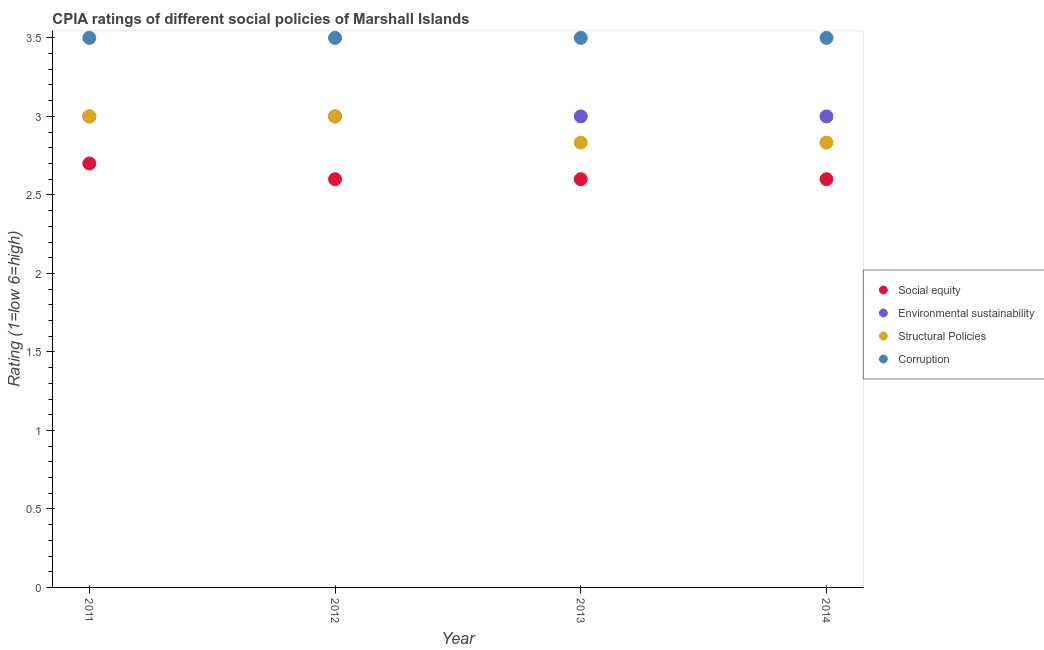How many different coloured dotlines are there?
Provide a succinct answer. 4. Is the number of dotlines equal to the number of legend labels?
Your answer should be compact. Yes. What is the cpia rating of environmental sustainability in 2011?
Your answer should be compact. 3. Across all years, what is the minimum cpia rating of structural policies?
Give a very brief answer. 2.83. In which year was the cpia rating of environmental sustainability minimum?
Provide a succinct answer. 2011. What is the average cpia rating of structural policies per year?
Provide a succinct answer. 2.92. In the year 2014, what is the difference between the cpia rating of social equity and cpia rating of structural policies?
Your response must be concise. -0.23. In how many years, is the cpia rating of social equity greater than 3.3?
Provide a short and direct response. 0. What is the ratio of the cpia rating of social equity in 2013 to that in 2014?
Make the answer very short. 1. Is the cpia rating of structural policies in 2012 less than that in 2014?
Provide a short and direct response. No. Is the difference between the cpia rating of structural policies in 2011 and 2012 greater than the difference between the cpia rating of social equity in 2011 and 2012?
Your answer should be very brief. No. What is the difference between the highest and the second highest cpia rating of structural policies?
Keep it short and to the point. 0. In how many years, is the cpia rating of corruption greater than the average cpia rating of corruption taken over all years?
Make the answer very short. 0. Is the sum of the cpia rating of structural policies in 2011 and 2014 greater than the maximum cpia rating of corruption across all years?
Keep it short and to the point. Yes. Is it the case that in every year, the sum of the cpia rating of structural policies and cpia rating of social equity is greater than the sum of cpia rating of corruption and cpia rating of environmental sustainability?
Your response must be concise. Yes. Is it the case that in every year, the sum of the cpia rating of social equity and cpia rating of environmental sustainability is greater than the cpia rating of structural policies?
Give a very brief answer. Yes. Is the cpia rating of social equity strictly less than the cpia rating of corruption over the years?
Provide a succinct answer. Yes. How many dotlines are there?
Offer a very short reply. 4. What is the difference between two consecutive major ticks on the Y-axis?
Make the answer very short. 0.5. Are the values on the major ticks of Y-axis written in scientific E-notation?
Give a very brief answer. No. How many legend labels are there?
Your answer should be very brief. 4. What is the title of the graph?
Provide a short and direct response. CPIA ratings of different social policies of Marshall Islands. What is the label or title of the X-axis?
Make the answer very short. Year. What is the Rating (1=low 6=high) in Corruption in 2011?
Your answer should be compact. 3.5. What is the Rating (1=low 6=high) in Social equity in 2012?
Give a very brief answer. 2.6. What is the Rating (1=low 6=high) of Structural Policies in 2012?
Offer a very short reply. 3. What is the Rating (1=low 6=high) in Social equity in 2013?
Your answer should be very brief. 2.6. What is the Rating (1=low 6=high) of Environmental sustainability in 2013?
Provide a short and direct response. 3. What is the Rating (1=low 6=high) of Structural Policies in 2013?
Make the answer very short. 2.83. What is the Rating (1=low 6=high) of Corruption in 2013?
Your answer should be very brief. 3.5. What is the Rating (1=low 6=high) of Social equity in 2014?
Ensure brevity in your answer.  2.6. What is the Rating (1=low 6=high) of Environmental sustainability in 2014?
Your answer should be compact. 3. What is the Rating (1=low 6=high) in Structural Policies in 2014?
Your response must be concise. 2.83. What is the Rating (1=low 6=high) in Corruption in 2014?
Offer a terse response. 3.5. Across all years, what is the maximum Rating (1=low 6=high) in Social equity?
Provide a succinct answer. 2.7. Across all years, what is the maximum Rating (1=low 6=high) in Environmental sustainability?
Ensure brevity in your answer.  3. Across all years, what is the maximum Rating (1=low 6=high) in Structural Policies?
Your response must be concise. 3. Across all years, what is the minimum Rating (1=low 6=high) of Structural Policies?
Offer a very short reply. 2.83. What is the total Rating (1=low 6=high) of Environmental sustainability in the graph?
Provide a succinct answer. 12. What is the total Rating (1=low 6=high) in Structural Policies in the graph?
Offer a very short reply. 11.67. What is the difference between the Rating (1=low 6=high) in Social equity in 2011 and that in 2012?
Your answer should be very brief. 0.1. What is the difference between the Rating (1=low 6=high) in Environmental sustainability in 2011 and that in 2012?
Your response must be concise. 0. What is the difference between the Rating (1=low 6=high) in Structural Policies in 2011 and that in 2012?
Your answer should be compact. 0. What is the difference between the Rating (1=low 6=high) in Social equity in 2011 and that in 2013?
Offer a terse response. 0.1. What is the difference between the Rating (1=low 6=high) of Structural Policies in 2011 and that in 2013?
Your response must be concise. 0.17. What is the difference between the Rating (1=low 6=high) of Corruption in 2011 and that in 2013?
Make the answer very short. 0. What is the difference between the Rating (1=low 6=high) in Social equity in 2012 and that in 2013?
Give a very brief answer. 0. What is the difference between the Rating (1=low 6=high) in Environmental sustainability in 2012 and that in 2013?
Your response must be concise. 0. What is the difference between the Rating (1=low 6=high) of Structural Policies in 2012 and that in 2013?
Ensure brevity in your answer.  0.17. What is the difference between the Rating (1=low 6=high) in Corruption in 2012 and that in 2013?
Your answer should be compact. 0. What is the difference between the Rating (1=low 6=high) in Social equity in 2012 and that in 2014?
Give a very brief answer. 0. What is the difference between the Rating (1=low 6=high) of Environmental sustainability in 2012 and that in 2014?
Your response must be concise. 0. What is the difference between the Rating (1=low 6=high) in Corruption in 2012 and that in 2014?
Your response must be concise. 0. What is the difference between the Rating (1=low 6=high) in Structural Policies in 2013 and that in 2014?
Provide a succinct answer. 0. What is the difference between the Rating (1=low 6=high) of Social equity in 2011 and the Rating (1=low 6=high) of Structural Policies in 2012?
Your answer should be very brief. -0.3. What is the difference between the Rating (1=low 6=high) in Social equity in 2011 and the Rating (1=low 6=high) in Corruption in 2012?
Offer a terse response. -0.8. What is the difference between the Rating (1=low 6=high) of Environmental sustainability in 2011 and the Rating (1=low 6=high) of Structural Policies in 2012?
Provide a short and direct response. 0. What is the difference between the Rating (1=low 6=high) in Environmental sustainability in 2011 and the Rating (1=low 6=high) in Corruption in 2012?
Offer a terse response. -0.5. What is the difference between the Rating (1=low 6=high) of Social equity in 2011 and the Rating (1=low 6=high) of Environmental sustainability in 2013?
Make the answer very short. -0.3. What is the difference between the Rating (1=low 6=high) in Social equity in 2011 and the Rating (1=low 6=high) in Structural Policies in 2013?
Give a very brief answer. -0.13. What is the difference between the Rating (1=low 6=high) in Social equity in 2011 and the Rating (1=low 6=high) in Corruption in 2013?
Your answer should be very brief. -0.8. What is the difference between the Rating (1=low 6=high) of Environmental sustainability in 2011 and the Rating (1=low 6=high) of Structural Policies in 2013?
Make the answer very short. 0.17. What is the difference between the Rating (1=low 6=high) of Environmental sustainability in 2011 and the Rating (1=low 6=high) of Corruption in 2013?
Provide a succinct answer. -0.5. What is the difference between the Rating (1=low 6=high) in Social equity in 2011 and the Rating (1=low 6=high) in Environmental sustainability in 2014?
Provide a short and direct response. -0.3. What is the difference between the Rating (1=low 6=high) in Social equity in 2011 and the Rating (1=low 6=high) in Structural Policies in 2014?
Provide a succinct answer. -0.13. What is the difference between the Rating (1=low 6=high) in Environmental sustainability in 2011 and the Rating (1=low 6=high) in Corruption in 2014?
Your answer should be compact. -0.5. What is the difference between the Rating (1=low 6=high) in Social equity in 2012 and the Rating (1=low 6=high) in Environmental sustainability in 2013?
Ensure brevity in your answer.  -0.4. What is the difference between the Rating (1=low 6=high) of Social equity in 2012 and the Rating (1=low 6=high) of Structural Policies in 2013?
Provide a succinct answer. -0.23. What is the difference between the Rating (1=low 6=high) of Environmental sustainability in 2012 and the Rating (1=low 6=high) of Structural Policies in 2013?
Offer a terse response. 0.17. What is the difference between the Rating (1=low 6=high) in Environmental sustainability in 2012 and the Rating (1=low 6=high) in Corruption in 2013?
Make the answer very short. -0.5. What is the difference between the Rating (1=low 6=high) of Structural Policies in 2012 and the Rating (1=low 6=high) of Corruption in 2013?
Offer a very short reply. -0.5. What is the difference between the Rating (1=low 6=high) in Social equity in 2012 and the Rating (1=low 6=high) in Environmental sustainability in 2014?
Provide a succinct answer. -0.4. What is the difference between the Rating (1=low 6=high) of Social equity in 2012 and the Rating (1=low 6=high) of Structural Policies in 2014?
Your response must be concise. -0.23. What is the difference between the Rating (1=low 6=high) of Social equity in 2012 and the Rating (1=low 6=high) of Corruption in 2014?
Keep it short and to the point. -0.9. What is the difference between the Rating (1=low 6=high) of Environmental sustainability in 2012 and the Rating (1=low 6=high) of Structural Policies in 2014?
Ensure brevity in your answer.  0.17. What is the difference between the Rating (1=low 6=high) of Social equity in 2013 and the Rating (1=low 6=high) of Environmental sustainability in 2014?
Give a very brief answer. -0.4. What is the difference between the Rating (1=low 6=high) of Social equity in 2013 and the Rating (1=low 6=high) of Structural Policies in 2014?
Keep it short and to the point. -0.23. What is the difference between the Rating (1=low 6=high) of Environmental sustainability in 2013 and the Rating (1=low 6=high) of Corruption in 2014?
Make the answer very short. -0.5. What is the average Rating (1=low 6=high) of Social equity per year?
Offer a terse response. 2.62. What is the average Rating (1=low 6=high) of Environmental sustainability per year?
Your answer should be very brief. 3. What is the average Rating (1=low 6=high) of Structural Policies per year?
Your answer should be compact. 2.92. In the year 2011, what is the difference between the Rating (1=low 6=high) of Environmental sustainability and Rating (1=low 6=high) of Structural Policies?
Your answer should be compact. 0. In the year 2011, what is the difference between the Rating (1=low 6=high) of Environmental sustainability and Rating (1=low 6=high) of Corruption?
Offer a very short reply. -0.5. In the year 2011, what is the difference between the Rating (1=low 6=high) in Structural Policies and Rating (1=low 6=high) in Corruption?
Keep it short and to the point. -0.5. In the year 2012, what is the difference between the Rating (1=low 6=high) of Social equity and Rating (1=low 6=high) of Corruption?
Your response must be concise. -0.9. In the year 2012, what is the difference between the Rating (1=low 6=high) of Environmental sustainability and Rating (1=low 6=high) of Structural Policies?
Provide a short and direct response. 0. In the year 2012, what is the difference between the Rating (1=low 6=high) of Environmental sustainability and Rating (1=low 6=high) of Corruption?
Your answer should be compact. -0.5. In the year 2013, what is the difference between the Rating (1=low 6=high) of Social equity and Rating (1=low 6=high) of Structural Policies?
Your answer should be compact. -0.23. In the year 2013, what is the difference between the Rating (1=low 6=high) in Environmental sustainability and Rating (1=low 6=high) in Structural Policies?
Offer a very short reply. 0.17. In the year 2013, what is the difference between the Rating (1=low 6=high) in Structural Policies and Rating (1=low 6=high) in Corruption?
Make the answer very short. -0.67. In the year 2014, what is the difference between the Rating (1=low 6=high) of Social equity and Rating (1=low 6=high) of Structural Policies?
Keep it short and to the point. -0.23. In the year 2014, what is the difference between the Rating (1=low 6=high) of Environmental sustainability and Rating (1=low 6=high) of Corruption?
Ensure brevity in your answer.  -0.5. In the year 2014, what is the difference between the Rating (1=low 6=high) of Structural Policies and Rating (1=low 6=high) of Corruption?
Provide a succinct answer. -0.67. What is the ratio of the Rating (1=low 6=high) of Social equity in 2011 to that in 2012?
Your answer should be compact. 1.04. What is the ratio of the Rating (1=low 6=high) of Environmental sustainability in 2011 to that in 2012?
Your answer should be compact. 1. What is the ratio of the Rating (1=low 6=high) in Structural Policies in 2011 to that in 2012?
Your answer should be compact. 1. What is the ratio of the Rating (1=low 6=high) of Social equity in 2011 to that in 2013?
Offer a terse response. 1.04. What is the ratio of the Rating (1=low 6=high) of Environmental sustainability in 2011 to that in 2013?
Keep it short and to the point. 1. What is the ratio of the Rating (1=low 6=high) of Structural Policies in 2011 to that in 2013?
Offer a terse response. 1.06. What is the ratio of the Rating (1=low 6=high) of Social equity in 2011 to that in 2014?
Ensure brevity in your answer.  1.04. What is the ratio of the Rating (1=low 6=high) in Structural Policies in 2011 to that in 2014?
Provide a short and direct response. 1.06. What is the ratio of the Rating (1=low 6=high) in Corruption in 2011 to that in 2014?
Offer a terse response. 1. What is the ratio of the Rating (1=low 6=high) in Social equity in 2012 to that in 2013?
Offer a terse response. 1. What is the ratio of the Rating (1=low 6=high) in Environmental sustainability in 2012 to that in 2013?
Make the answer very short. 1. What is the ratio of the Rating (1=low 6=high) of Structural Policies in 2012 to that in 2013?
Give a very brief answer. 1.06. What is the ratio of the Rating (1=low 6=high) in Social equity in 2012 to that in 2014?
Offer a terse response. 1. What is the ratio of the Rating (1=low 6=high) of Structural Policies in 2012 to that in 2014?
Provide a short and direct response. 1.06. What is the ratio of the Rating (1=low 6=high) of Corruption in 2012 to that in 2014?
Provide a succinct answer. 1. What is the ratio of the Rating (1=low 6=high) of Social equity in 2013 to that in 2014?
Keep it short and to the point. 1. What is the ratio of the Rating (1=low 6=high) of Environmental sustainability in 2013 to that in 2014?
Your answer should be very brief. 1. What is the ratio of the Rating (1=low 6=high) of Structural Policies in 2013 to that in 2014?
Ensure brevity in your answer.  1. What is the difference between the highest and the second highest Rating (1=low 6=high) of Environmental sustainability?
Ensure brevity in your answer.  0. What is the difference between the highest and the second highest Rating (1=low 6=high) in Corruption?
Offer a very short reply. 0. What is the difference between the highest and the lowest Rating (1=low 6=high) of Social equity?
Your response must be concise. 0.1. What is the difference between the highest and the lowest Rating (1=low 6=high) of Corruption?
Ensure brevity in your answer.  0. 